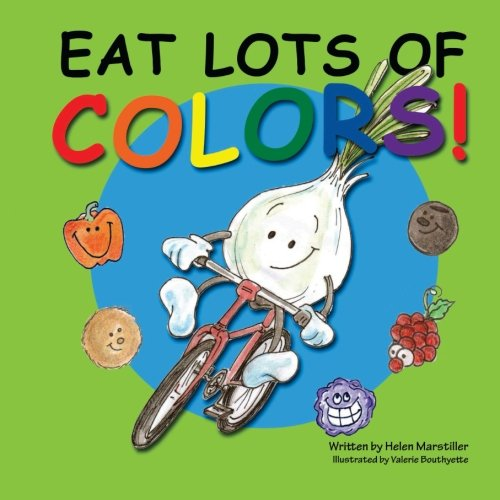Is this a kids book? Yes, this book is indeed designed for children, featuring eye-catching illustrations and easy-to-understand text that make learning about nutrition fun and accessible for young readers. 